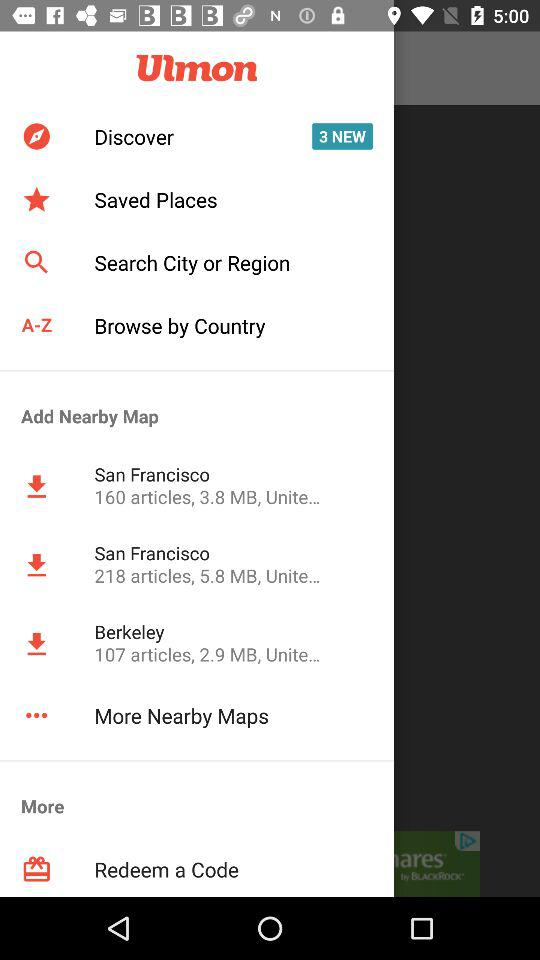What's the total number of articles in the Berkeley map? The total number of articles is 107. 